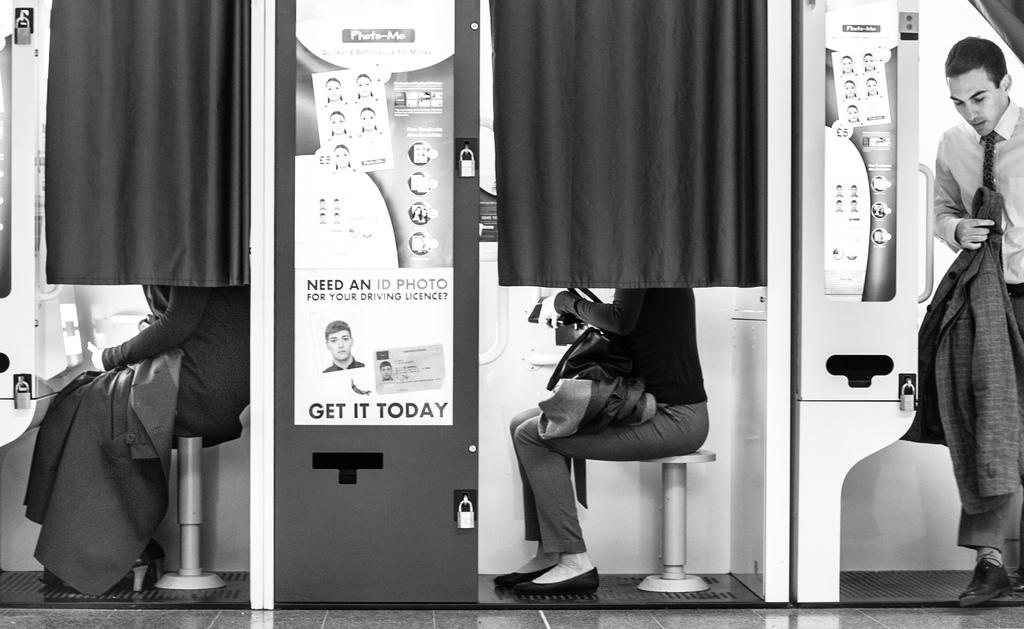How many people are sitting in the photo booth in the image? There are two women sitting in the photo booth in the image. What is happening with the photo booth in the image? There is a person coming out of the photo booth in the image. What type of decorations can be seen in the image? Posters are visible in the image. What type of window treatment is present in the image? Curtains are present in the image. What type of bird can be seen flying near the photo booth in the image? There is no bird visible in the image; it only features two women sitting in the photo booth, a person coming out of the photo booth, posters, and curtains. What type of toy is being played with by the mother in the image? There is no mother or toy present in the image. 